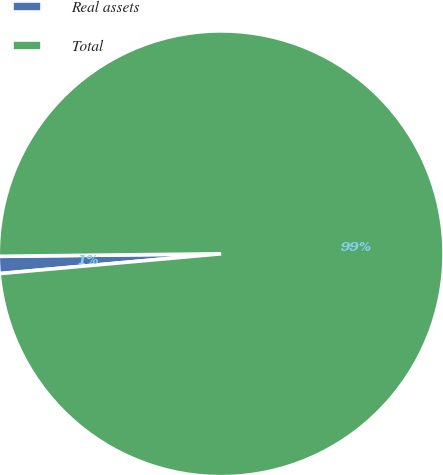Convert chart. <chart><loc_0><loc_0><loc_500><loc_500><pie_chart><fcel>Real assets<fcel>Total<nl><fcel>1.24%<fcel>98.76%<nl></chart> 